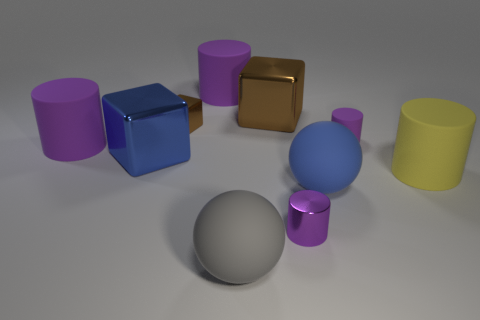How would you describe the arrangement of objects in this scene? The arrangement of objects seems intentionally composed, with a variety of geometric shapes, including cylinders and cubes, spread out across the scene. There's a sense of balance, yet it appears random, lacking any specific pattern. Could the arrangement be symbolically representing anything? While the placement of the objects might not symbolize anything in a conventional sense, it could depict something more abstract, such as the diversity of shapes and colors in an organized chaos, or it could simply be a study of forms and shades in a three-dimensional space. 